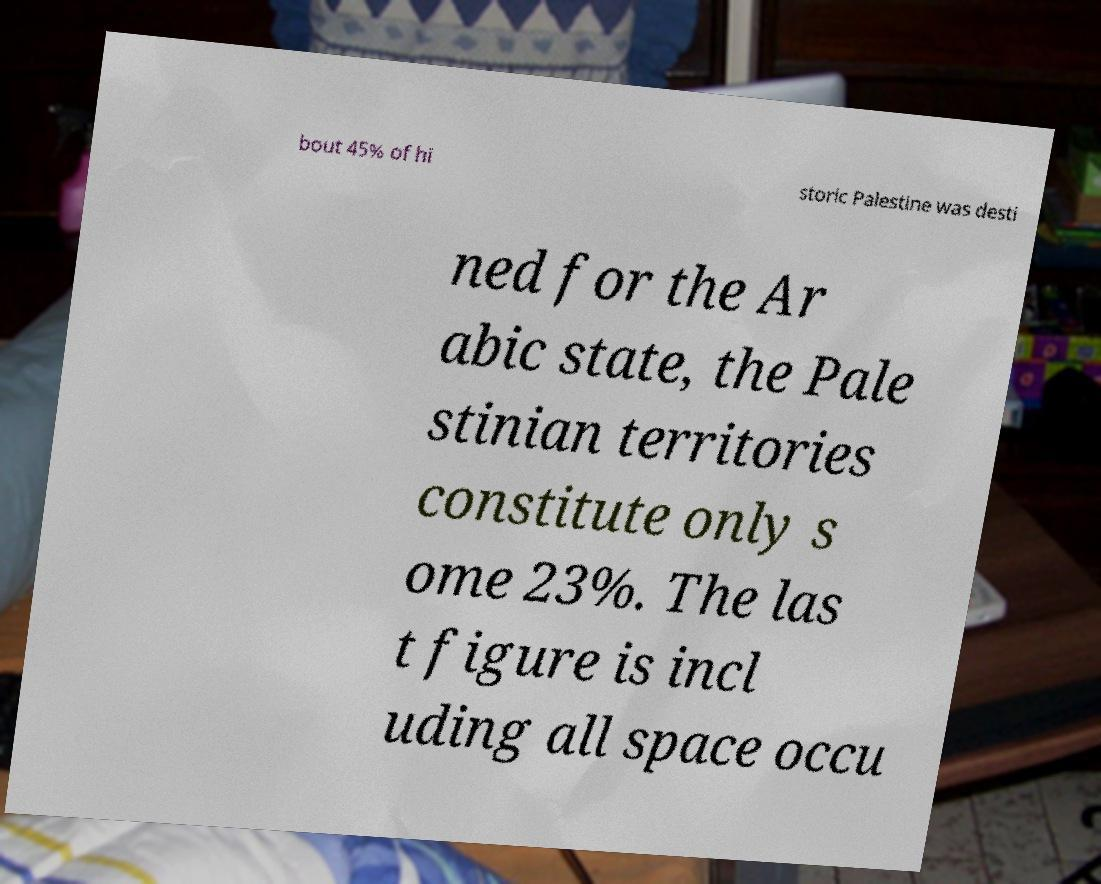What messages or text are displayed in this image? I need them in a readable, typed format. bout 45% of hi storic Palestine was desti ned for the Ar abic state, the Pale stinian territories constitute only s ome 23%. The las t figure is incl uding all space occu 